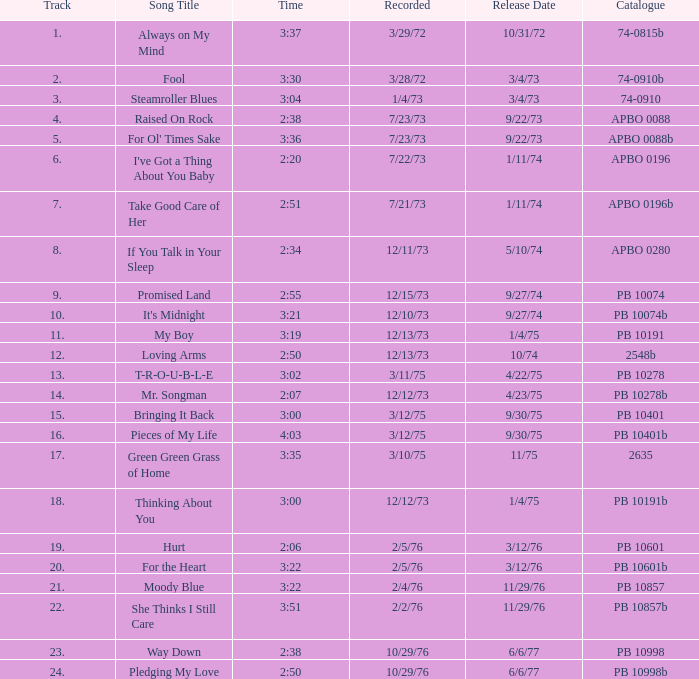Could you parse the entire table? {'header': ['Track', 'Song Title', 'Time', 'Recorded', 'Release Date', 'Catalogue'], 'rows': [['1.', 'Always on My Mind', '3:37', '3/29/72', '10/31/72', '74-0815b'], ['2.', 'Fool', '3:30', '3/28/72', '3/4/73', '74-0910b'], ['3.', 'Steamroller Blues', '3:04', '1/4/73', '3/4/73', '74-0910'], ['4.', 'Raised On Rock', '2:38', '7/23/73', '9/22/73', 'APBO 0088'], ['5.', "For Ol' Times Sake", '3:36', '7/23/73', '9/22/73', 'APBO 0088b'], ['6.', "I've Got a Thing About You Baby", '2:20', '7/22/73', '1/11/74', 'APBO 0196'], ['7.', 'Take Good Care of Her', '2:51', '7/21/73', '1/11/74', 'APBO 0196b'], ['8.', 'If You Talk in Your Sleep', '2:34', '12/11/73', '5/10/74', 'APBO 0280'], ['9.', 'Promised Land', '2:55', '12/15/73', '9/27/74', 'PB 10074'], ['10.', "It's Midnight", '3:21', '12/10/73', '9/27/74', 'PB 10074b'], ['11.', 'My Boy', '3:19', '12/13/73', '1/4/75', 'PB 10191'], ['12.', 'Loving Arms', '2:50', '12/13/73', '10/74', '2548b'], ['13.', 'T-R-O-U-B-L-E', '3:02', '3/11/75', '4/22/75', 'PB 10278'], ['14.', 'Mr. Songman', '2:07', '12/12/73', '4/23/75', 'PB 10278b'], ['15.', 'Bringing It Back', '3:00', '3/12/75', '9/30/75', 'PB 10401'], ['16.', 'Pieces of My Life', '4:03', '3/12/75', '9/30/75', 'PB 10401b'], ['17.', 'Green Green Grass of Home', '3:35', '3/10/75', '11/75', '2635'], ['18.', 'Thinking About You', '3:00', '12/12/73', '1/4/75', 'PB 10191b'], ['19.', 'Hurt', '2:06', '2/5/76', '3/12/76', 'PB 10601'], ['20.', 'For the Heart', '3:22', '2/5/76', '3/12/76', 'PB 10601b'], ['21.', 'Moody Blue', '3:22', '2/4/76', '11/29/76', 'PB 10857'], ['22.', 'She Thinks I Still Care', '3:51', '2/2/76', '11/29/76', 'PB 10857b'], ['23.', 'Way Down', '2:38', '10/29/76', '6/6/77', 'PB 10998'], ['24.', 'Pledging My Love', '2:50', '10/29/76', '6/6/77', 'PB 10998b']]} Tell me the recorded for time of 2:50 and released date of 6/6/77 with track more than 20 10/29/76. 